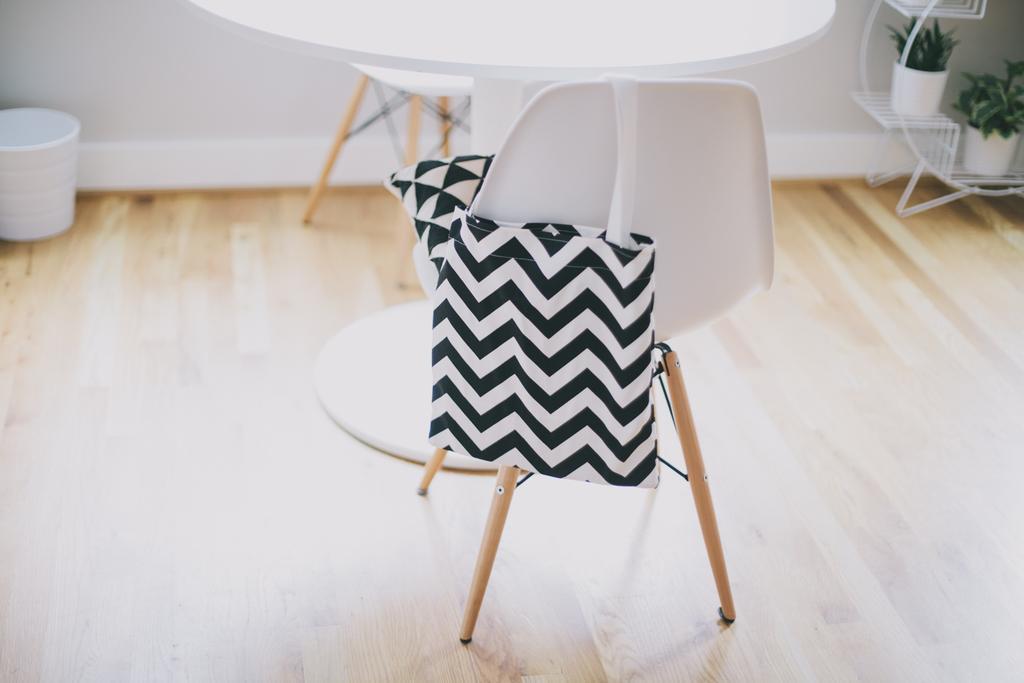Describe this image in one or two sentences. in a room there is a chair to which a black and white bag is hung. in front of it there is a white table. at the right there is a white pot of plants. at the left there is a white pot. the floor is wooden colored. 